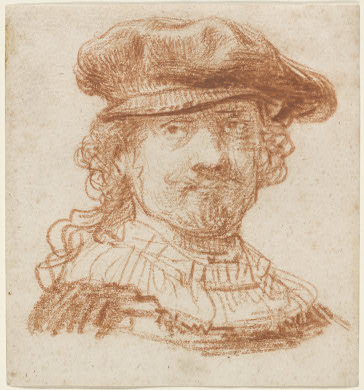Can you describe the main features of this image for me?
 The image portrays a man, captured in a three-quarter view with his head slightly tilted to the left. He is adorned with a hat and a ruff collar, adding a touch of elegance to his persona. The portrait is drawn in red chalk on a beige paper, creating a warm and inviting color palette. The artist has employed a loose, sketchy style, with visible hatching and cross-hatching, adding depth and texture to the image. The art style is Baroque, characterized by dramatic intensity and strong contrasts, while the genre is portraiture, focusing on the depiction of the individual's features and expressions. 